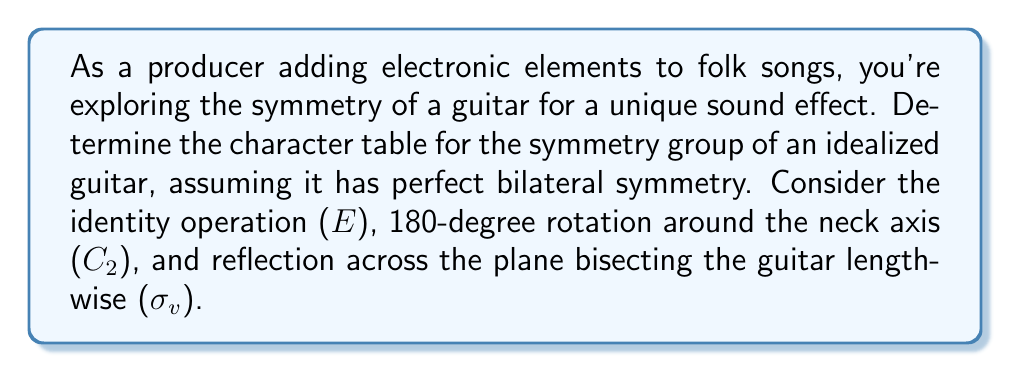Can you answer this question? 1) First, identify the symmetry group:
   The symmetry operations form the group C2v, which has order 4.

2) List the symmetry operations:
   E: identity
   C2: 180-degree rotation around the neck axis
   σv: reflection across the plane bisecting the guitar lengthwise
   σv': reflection across the plane perpendicular to σv

3) Determine the conjugacy classes:
   Each element is in its own conjugacy class as the group is abelian.

4) Find the number of irreducible representations:
   The number of irreducible representations equals the number of conjugacy classes, which is 4.

5) Determine the dimensions of the irreducible representations:
   $$4 = 1^2 + 1^2 + 1^2 + 1^2$$
   So, all irreducible representations are 1-dimensional.

6) Construct the character table:
   - The first row and column are always filled with 1's.
   - For C2v, we know there are four 1-dimensional irreducible representations: A1, A2, B1, and B2.
   - A1 is the trivial representation (all 1's).
   - For C2, the characters are 1 for A1 and A2, -1 for B1 and B2.
   - For σv, the characters are 1 for A1 and B1, -1 for A2 and B2.
   - For σv', the characters are 1 for A1 and B2, -1 for A2 and B1.

7) The completed character table:

   $$
   \begin{array}{c|cccc}
   C_{2v} & E & C_2 & \sigma_v & \sigma_v' \\
   \hline
   A_1 & 1 & 1 & 1 & 1 \\
   A_2 & 1 & 1 & -1 & -1 \\
   B_1 & 1 & -1 & 1 & -1 \\
   B_2 & 1 & -1 & -1 & 1
   \end{array}
   $$

This character table can be used to analyze how different electronic effects might interact with the guitar's symmetry in your production process.
Answer: $$
\begin{array}{c|cccc}
C_{2v} & E & C_2 & \sigma_v & \sigma_v' \\
\hline
A_1 & 1 & 1 & 1 & 1 \\
A_2 & 1 & 1 & -1 & -1 \\
B_1 & 1 & -1 & 1 & -1 \\
B_2 & 1 & -1 & -1 & 1
\end{array}
$$ 